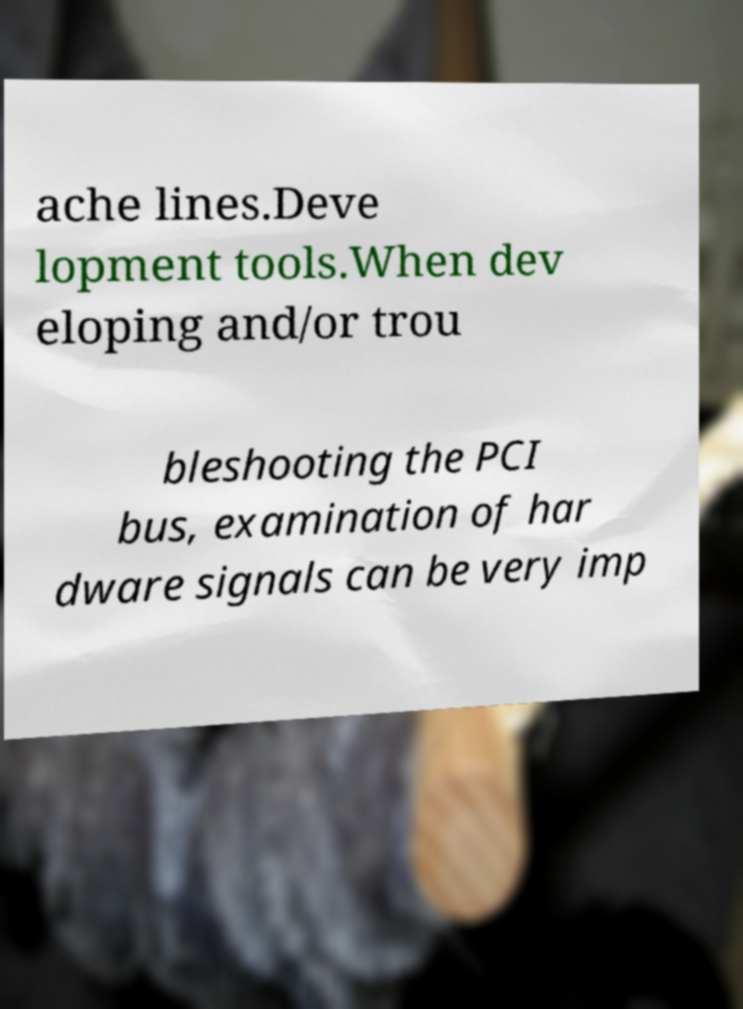For documentation purposes, I need the text within this image transcribed. Could you provide that? ache lines.Deve lopment tools.When dev eloping and/or trou bleshooting the PCI bus, examination of har dware signals can be very imp 